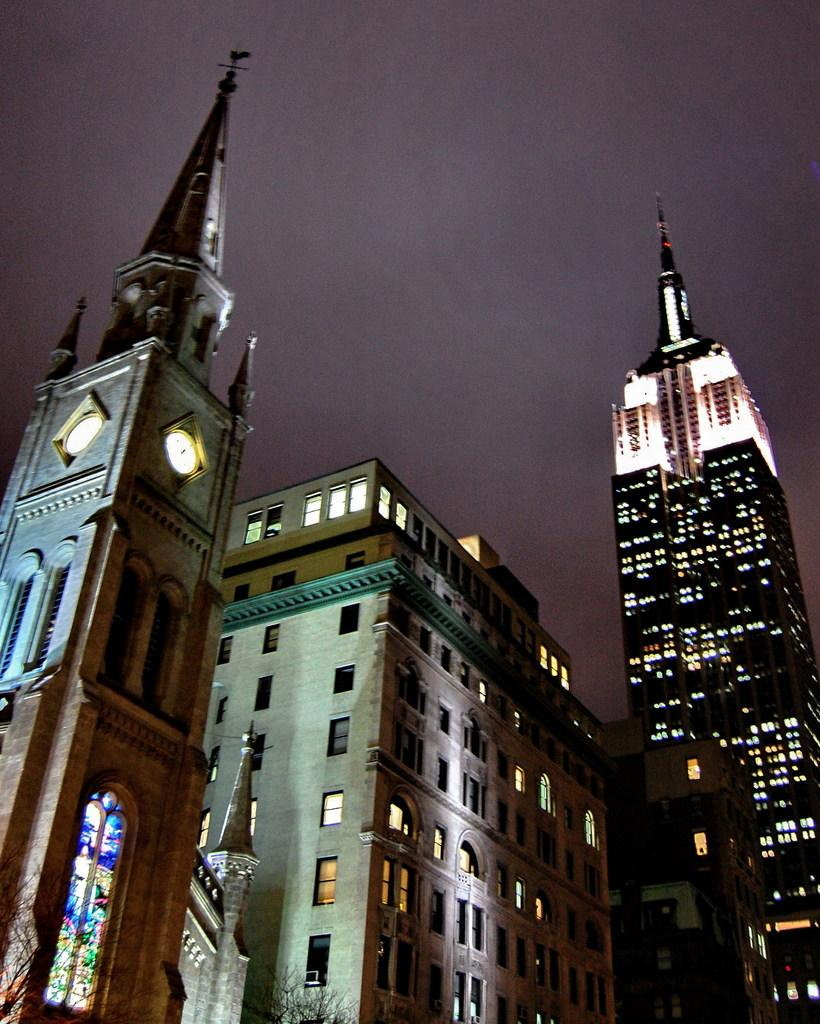What type of structures are present in the image? There are buildings in the image. What other natural elements can be seen in the image? There are trees in the image. What time-related objects are visible on the walls of the buildings? There are clocks on the wall in the image. What can be seen inside the buildings? There are lights inside the buildings in the image. What is visible at the top of the image? The sky is visible at the top of the image. Can you tell me how many books are in the library depicted in the image? There is no library present in the image; it features buildings, trees, clocks, lights, and the sky. Is there any rain visible in the image? There is no rain present in the image. 